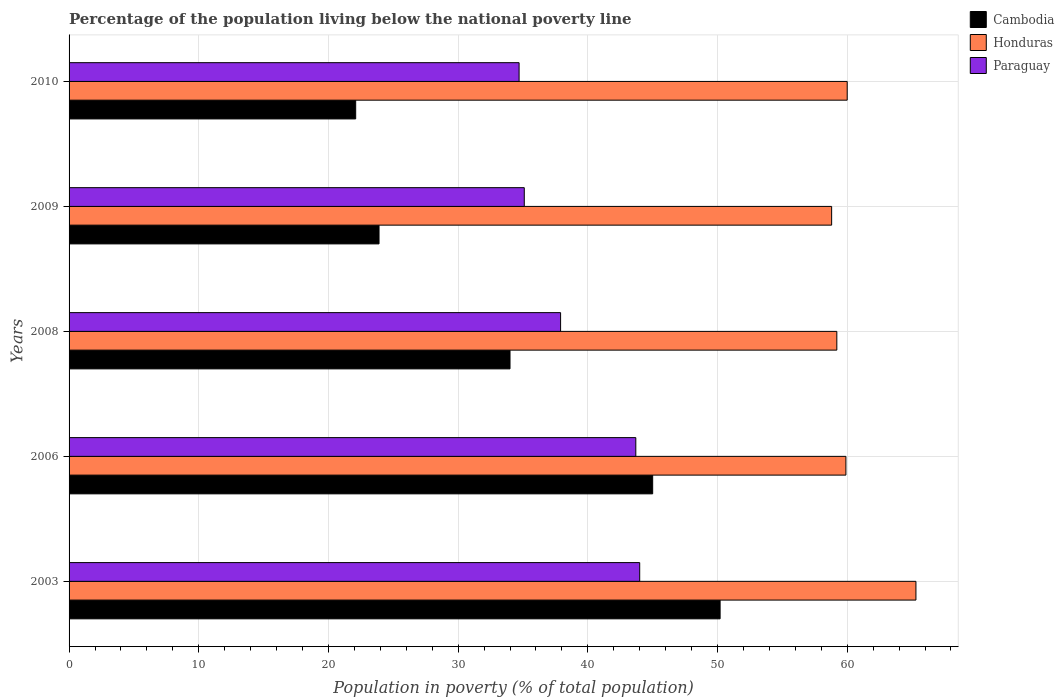How many groups of bars are there?
Keep it short and to the point. 5. Are the number of bars per tick equal to the number of legend labels?
Your response must be concise. Yes. How many bars are there on the 3rd tick from the bottom?
Offer a very short reply. 3. What is the label of the 4th group of bars from the top?
Your answer should be compact. 2006. In how many cases, is the number of bars for a given year not equal to the number of legend labels?
Ensure brevity in your answer.  0. Across all years, what is the maximum percentage of the population living below the national poverty line in Honduras?
Your response must be concise. 65.3. Across all years, what is the minimum percentage of the population living below the national poverty line in Paraguay?
Make the answer very short. 34.7. In which year was the percentage of the population living below the national poverty line in Honduras maximum?
Keep it short and to the point. 2003. In which year was the percentage of the population living below the national poverty line in Cambodia minimum?
Make the answer very short. 2010. What is the total percentage of the population living below the national poverty line in Cambodia in the graph?
Your answer should be compact. 175.2. What is the difference between the percentage of the population living below the national poverty line in Honduras in 2006 and that in 2010?
Keep it short and to the point. -0.1. What is the difference between the percentage of the population living below the national poverty line in Cambodia in 2008 and the percentage of the population living below the national poverty line in Paraguay in 2003?
Your answer should be very brief. -10. What is the average percentage of the population living below the national poverty line in Cambodia per year?
Your response must be concise. 35.04. In the year 2010, what is the difference between the percentage of the population living below the national poverty line in Paraguay and percentage of the population living below the national poverty line in Honduras?
Your answer should be very brief. -25.3. In how many years, is the percentage of the population living below the national poverty line in Honduras greater than 2 %?
Provide a short and direct response. 5. What is the ratio of the percentage of the population living below the national poverty line in Cambodia in 2003 to that in 2006?
Provide a short and direct response. 1.12. Is the percentage of the population living below the national poverty line in Paraguay in 2003 less than that in 2010?
Offer a terse response. No. Is the difference between the percentage of the population living below the national poverty line in Paraguay in 2003 and 2009 greater than the difference between the percentage of the population living below the national poverty line in Honduras in 2003 and 2009?
Ensure brevity in your answer.  Yes. What is the difference between the highest and the second highest percentage of the population living below the national poverty line in Cambodia?
Offer a terse response. 5.2. What is the difference between the highest and the lowest percentage of the population living below the national poverty line in Paraguay?
Provide a short and direct response. 9.3. In how many years, is the percentage of the population living below the national poverty line in Paraguay greater than the average percentage of the population living below the national poverty line in Paraguay taken over all years?
Make the answer very short. 2. What does the 2nd bar from the top in 2003 represents?
Ensure brevity in your answer.  Honduras. What does the 1st bar from the bottom in 2003 represents?
Provide a short and direct response. Cambodia. Is it the case that in every year, the sum of the percentage of the population living below the national poverty line in Honduras and percentage of the population living below the national poverty line in Cambodia is greater than the percentage of the population living below the national poverty line in Paraguay?
Your answer should be compact. Yes. Are all the bars in the graph horizontal?
Provide a short and direct response. Yes. How many legend labels are there?
Your answer should be compact. 3. How are the legend labels stacked?
Make the answer very short. Vertical. What is the title of the graph?
Your answer should be compact. Percentage of the population living below the national poverty line. What is the label or title of the X-axis?
Keep it short and to the point. Population in poverty (% of total population). What is the label or title of the Y-axis?
Your answer should be very brief. Years. What is the Population in poverty (% of total population) in Cambodia in 2003?
Provide a succinct answer. 50.2. What is the Population in poverty (% of total population) in Honduras in 2003?
Give a very brief answer. 65.3. What is the Population in poverty (% of total population) of Paraguay in 2003?
Your response must be concise. 44. What is the Population in poverty (% of total population) of Cambodia in 2006?
Offer a terse response. 45. What is the Population in poverty (% of total population) in Honduras in 2006?
Ensure brevity in your answer.  59.9. What is the Population in poverty (% of total population) of Paraguay in 2006?
Your answer should be compact. 43.7. What is the Population in poverty (% of total population) of Honduras in 2008?
Provide a short and direct response. 59.2. What is the Population in poverty (% of total population) of Paraguay in 2008?
Your response must be concise. 37.9. What is the Population in poverty (% of total population) in Cambodia in 2009?
Your response must be concise. 23.9. What is the Population in poverty (% of total population) in Honduras in 2009?
Give a very brief answer. 58.8. What is the Population in poverty (% of total population) of Paraguay in 2009?
Provide a short and direct response. 35.1. What is the Population in poverty (% of total population) of Cambodia in 2010?
Offer a very short reply. 22.1. What is the Population in poverty (% of total population) of Honduras in 2010?
Provide a short and direct response. 60. What is the Population in poverty (% of total population) of Paraguay in 2010?
Give a very brief answer. 34.7. Across all years, what is the maximum Population in poverty (% of total population) in Cambodia?
Provide a succinct answer. 50.2. Across all years, what is the maximum Population in poverty (% of total population) of Honduras?
Keep it short and to the point. 65.3. Across all years, what is the maximum Population in poverty (% of total population) in Paraguay?
Make the answer very short. 44. Across all years, what is the minimum Population in poverty (% of total population) of Cambodia?
Your answer should be compact. 22.1. Across all years, what is the minimum Population in poverty (% of total population) in Honduras?
Make the answer very short. 58.8. Across all years, what is the minimum Population in poverty (% of total population) in Paraguay?
Give a very brief answer. 34.7. What is the total Population in poverty (% of total population) of Cambodia in the graph?
Provide a succinct answer. 175.2. What is the total Population in poverty (% of total population) of Honduras in the graph?
Make the answer very short. 303.2. What is the total Population in poverty (% of total population) in Paraguay in the graph?
Make the answer very short. 195.4. What is the difference between the Population in poverty (% of total population) of Cambodia in 2003 and that in 2006?
Your response must be concise. 5.2. What is the difference between the Population in poverty (% of total population) of Honduras in 2003 and that in 2006?
Give a very brief answer. 5.4. What is the difference between the Population in poverty (% of total population) in Paraguay in 2003 and that in 2006?
Your answer should be very brief. 0.3. What is the difference between the Population in poverty (% of total population) of Paraguay in 2003 and that in 2008?
Give a very brief answer. 6.1. What is the difference between the Population in poverty (% of total population) in Cambodia in 2003 and that in 2009?
Your answer should be compact. 26.3. What is the difference between the Population in poverty (% of total population) of Honduras in 2003 and that in 2009?
Your answer should be compact. 6.5. What is the difference between the Population in poverty (% of total population) of Paraguay in 2003 and that in 2009?
Your answer should be very brief. 8.9. What is the difference between the Population in poverty (% of total population) in Cambodia in 2003 and that in 2010?
Make the answer very short. 28.1. What is the difference between the Population in poverty (% of total population) in Honduras in 2003 and that in 2010?
Make the answer very short. 5.3. What is the difference between the Population in poverty (% of total population) in Paraguay in 2003 and that in 2010?
Make the answer very short. 9.3. What is the difference between the Population in poverty (% of total population) of Paraguay in 2006 and that in 2008?
Offer a terse response. 5.8. What is the difference between the Population in poverty (% of total population) in Cambodia in 2006 and that in 2009?
Provide a succinct answer. 21.1. What is the difference between the Population in poverty (% of total population) in Honduras in 2006 and that in 2009?
Provide a short and direct response. 1.1. What is the difference between the Population in poverty (% of total population) in Cambodia in 2006 and that in 2010?
Provide a short and direct response. 22.9. What is the difference between the Population in poverty (% of total population) in Paraguay in 2006 and that in 2010?
Offer a very short reply. 9. What is the difference between the Population in poverty (% of total population) in Cambodia in 2008 and that in 2009?
Provide a short and direct response. 10.1. What is the difference between the Population in poverty (% of total population) in Paraguay in 2008 and that in 2009?
Offer a very short reply. 2.8. What is the difference between the Population in poverty (% of total population) in Cambodia in 2008 and that in 2010?
Your answer should be compact. 11.9. What is the difference between the Population in poverty (% of total population) in Honduras in 2008 and that in 2010?
Give a very brief answer. -0.8. What is the difference between the Population in poverty (% of total population) of Paraguay in 2008 and that in 2010?
Ensure brevity in your answer.  3.2. What is the difference between the Population in poverty (% of total population) of Cambodia in 2009 and that in 2010?
Your response must be concise. 1.8. What is the difference between the Population in poverty (% of total population) of Cambodia in 2003 and the Population in poverty (% of total population) of Honduras in 2006?
Make the answer very short. -9.7. What is the difference between the Population in poverty (% of total population) in Honduras in 2003 and the Population in poverty (% of total population) in Paraguay in 2006?
Your response must be concise. 21.6. What is the difference between the Population in poverty (% of total population) in Cambodia in 2003 and the Population in poverty (% of total population) in Paraguay in 2008?
Make the answer very short. 12.3. What is the difference between the Population in poverty (% of total population) in Honduras in 2003 and the Population in poverty (% of total population) in Paraguay in 2008?
Give a very brief answer. 27.4. What is the difference between the Population in poverty (% of total population) in Cambodia in 2003 and the Population in poverty (% of total population) in Honduras in 2009?
Your answer should be very brief. -8.6. What is the difference between the Population in poverty (% of total population) in Honduras in 2003 and the Population in poverty (% of total population) in Paraguay in 2009?
Keep it short and to the point. 30.2. What is the difference between the Population in poverty (% of total population) of Cambodia in 2003 and the Population in poverty (% of total population) of Honduras in 2010?
Provide a succinct answer. -9.8. What is the difference between the Population in poverty (% of total population) in Cambodia in 2003 and the Population in poverty (% of total population) in Paraguay in 2010?
Your answer should be compact. 15.5. What is the difference between the Population in poverty (% of total population) of Honduras in 2003 and the Population in poverty (% of total population) of Paraguay in 2010?
Ensure brevity in your answer.  30.6. What is the difference between the Population in poverty (% of total population) of Honduras in 2006 and the Population in poverty (% of total population) of Paraguay in 2008?
Provide a short and direct response. 22. What is the difference between the Population in poverty (% of total population) in Cambodia in 2006 and the Population in poverty (% of total population) in Honduras in 2009?
Provide a short and direct response. -13.8. What is the difference between the Population in poverty (% of total population) in Honduras in 2006 and the Population in poverty (% of total population) in Paraguay in 2009?
Your answer should be very brief. 24.8. What is the difference between the Population in poverty (% of total population) of Honduras in 2006 and the Population in poverty (% of total population) of Paraguay in 2010?
Give a very brief answer. 25.2. What is the difference between the Population in poverty (% of total population) of Cambodia in 2008 and the Population in poverty (% of total population) of Honduras in 2009?
Provide a succinct answer. -24.8. What is the difference between the Population in poverty (% of total population) of Cambodia in 2008 and the Population in poverty (% of total population) of Paraguay in 2009?
Give a very brief answer. -1.1. What is the difference between the Population in poverty (% of total population) in Honduras in 2008 and the Population in poverty (% of total population) in Paraguay in 2009?
Provide a short and direct response. 24.1. What is the difference between the Population in poverty (% of total population) of Cambodia in 2008 and the Population in poverty (% of total population) of Honduras in 2010?
Your answer should be compact. -26. What is the difference between the Population in poverty (% of total population) of Cambodia in 2008 and the Population in poverty (% of total population) of Paraguay in 2010?
Offer a very short reply. -0.7. What is the difference between the Population in poverty (% of total population) in Honduras in 2008 and the Population in poverty (% of total population) in Paraguay in 2010?
Offer a terse response. 24.5. What is the difference between the Population in poverty (% of total population) in Cambodia in 2009 and the Population in poverty (% of total population) in Honduras in 2010?
Offer a very short reply. -36.1. What is the difference between the Population in poverty (% of total population) in Honduras in 2009 and the Population in poverty (% of total population) in Paraguay in 2010?
Ensure brevity in your answer.  24.1. What is the average Population in poverty (% of total population) of Cambodia per year?
Keep it short and to the point. 35.04. What is the average Population in poverty (% of total population) in Honduras per year?
Your answer should be compact. 60.64. What is the average Population in poverty (% of total population) in Paraguay per year?
Offer a very short reply. 39.08. In the year 2003, what is the difference between the Population in poverty (% of total population) of Cambodia and Population in poverty (% of total population) of Honduras?
Your answer should be compact. -15.1. In the year 2003, what is the difference between the Population in poverty (% of total population) in Cambodia and Population in poverty (% of total population) in Paraguay?
Your answer should be very brief. 6.2. In the year 2003, what is the difference between the Population in poverty (% of total population) in Honduras and Population in poverty (% of total population) in Paraguay?
Provide a short and direct response. 21.3. In the year 2006, what is the difference between the Population in poverty (% of total population) of Cambodia and Population in poverty (% of total population) of Honduras?
Provide a short and direct response. -14.9. In the year 2006, what is the difference between the Population in poverty (% of total population) in Honduras and Population in poverty (% of total population) in Paraguay?
Offer a terse response. 16.2. In the year 2008, what is the difference between the Population in poverty (% of total population) of Cambodia and Population in poverty (% of total population) of Honduras?
Make the answer very short. -25.2. In the year 2008, what is the difference between the Population in poverty (% of total population) in Cambodia and Population in poverty (% of total population) in Paraguay?
Keep it short and to the point. -3.9. In the year 2008, what is the difference between the Population in poverty (% of total population) in Honduras and Population in poverty (% of total population) in Paraguay?
Make the answer very short. 21.3. In the year 2009, what is the difference between the Population in poverty (% of total population) of Cambodia and Population in poverty (% of total population) of Honduras?
Offer a very short reply. -34.9. In the year 2009, what is the difference between the Population in poverty (% of total population) in Cambodia and Population in poverty (% of total population) in Paraguay?
Make the answer very short. -11.2. In the year 2009, what is the difference between the Population in poverty (% of total population) of Honduras and Population in poverty (% of total population) of Paraguay?
Ensure brevity in your answer.  23.7. In the year 2010, what is the difference between the Population in poverty (% of total population) in Cambodia and Population in poverty (% of total population) in Honduras?
Provide a succinct answer. -37.9. In the year 2010, what is the difference between the Population in poverty (% of total population) in Cambodia and Population in poverty (% of total population) in Paraguay?
Provide a succinct answer. -12.6. In the year 2010, what is the difference between the Population in poverty (% of total population) of Honduras and Population in poverty (% of total population) of Paraguay?
Offer a terse response. 25.3. What is the ratio of the Population in poverty (% of total population) of Cambodia in 2003 to that in 2006?
Give a very brief answer. 1.12. What is the ratio of the Population in poverty (% of total population) of Honduras in 2003 to that in 2006?
Offer a terse response. 1.09. What is the ratio of the Population in poverty (% of total population) in Cambodia in 2003 to that in 2008?
Make the answer very short. 1.48. What is the ratio of the Population in poverty (% of total population) of Honduras in 2003 to that in 2008?
Make the answer very short. 1.1. What is the ratio of the Population in poverty (% of total population) of Paraguay in 2003 to that in 2008?
Provide a short and direct response. 1.16. What is the ratio of the Population in poverty (% of total population) of Cambodia in 2003 to that in 2009?
Ensure brevity in your answer.  2.1. What is the ratio of the Population in poverty (% of total population) in Honduras in 2003 to that in 2009?
Provide a short and direct response. 1.11. What is the ratio of the Population in poverty (% of total population) of Paraguay in 2003 to that in 2009?
Give a very brief answer. 1.25. What is the ratio of the Population in poverty (% of total population) of Cambodia in 2003 to that in 2010?
Offer a terse response. 2.27. What is the ratio of the Population in poverty (% of total population) of Honduras in 2003 to that in 2010?
Keep it short and to the point. 1.09. What is the ratio of the Population in poverty (% of total population) in Paraguay in 2003 to that in 2010?
Offer a very short reply. 1.27. What is the ratio of the Population in poverty (% of total population) of Cambodia in 2006 to that in 2008?
Make the answer very short. 1.32. What is the ratio of the Population in poverty (% of total population) in Honduras in 2006 to that in 2008?
Give a very brief answer. 1.01. What is the ratio of the Population in poverty (% of total population) of Paraguay in 2006 to that in 2008?
Your answer should be compact. 1.15. What is the ratio of the Population in poverty (% of total population) of Cambodia in 2006 to that in 2009?
Give a very brief answer. 1.88. What is the ratio of the Population in poverty (% of total population) of Honduras in 2006 to that in 2009?
Your response must be concise. 1.02. What is the ratio of the Population in poverty (% of total population) in Paraguay in 2006 to that in 2009?
Provide a succinct answer. 1.25. What is the ratio of the Population in poverty (% of total population) of Cambodia in 2006 to that in 2010?
Your answer should be compact. 2.04. What is the ratio of the Population in poverty (% of total population) in Paraguay in 2006 to that in 2010?
Your answer should be compact. 1.26. What is the ratio of the Population in poverty (% of total population) of Cambodia in 2008 to that in 2009?
Provide a short and direct response. 1.42. What is the ratio of the Population in poverty (% of total population) of Honduras in 2008 to that in 2009?
Provide a succinct answer. 1.01. What is the ratio of the Population in poverty (% of total population) in Paraguay in 2008 to that in 2009?
Your answer should be very brief. 1.08. What is the ratio of the Population in poverty (% of total population) in Cambodia in 2008 to that in 2010?
Your response must be concise. 1.54. What is the ratio of the Population in poverty (% of total population) in Honduras in 2008 to that in 2010?
Provide a succinct answer. 0.99. What is the ratio of the Population in poverty (% of total population) in Paraguay in 2008 to that in 2010?
Offer a terse response. 1.09. What is the ratio of the Population in poverty (% of total population) in Cambodia in 2009 to that in 2010?
Provide a succinct answer. 1.08. What is the ratio of the Population in poverty (% of total population) in Paraguay in 2009 to that in 2010?
Your response must be concise. 1.01. What is the difference between the highest and the second highest Population in poverty (% of total population) in Honduras?
Your answer should be very brief. 5.3. What is the difference between the highest and the second highest Population in poverty (% of total population) in Paraguay?
Make the answer very short. 0.3. What is the difference between the highest and the lowest Population in poverty (% of total population) of Cambodia?
Your response must be concise. 28.1. What is the difference between the highest and the lowest Population in poverty (% of total population) in Paraguay?
Offer a very short reply. 9.3. 